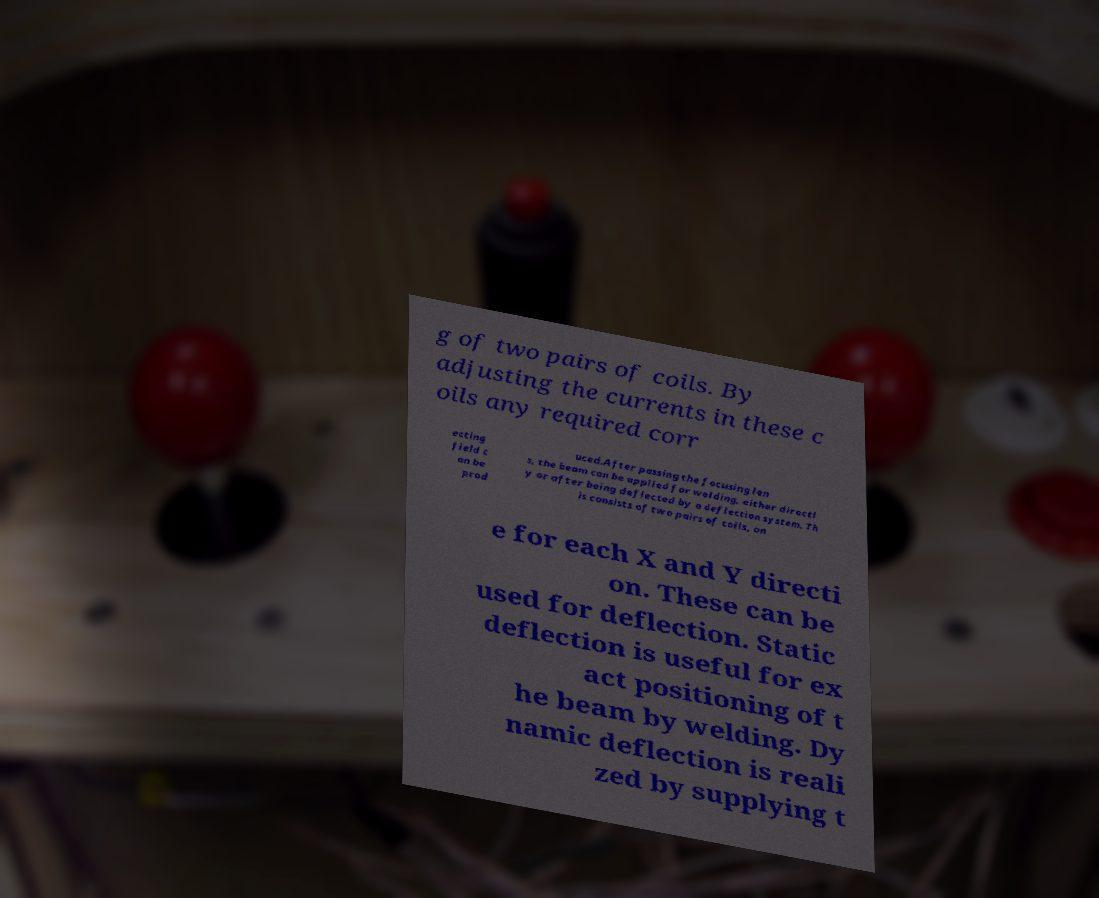What messages or text are displayed in this image? I need them in a readable, typed format. g of two pairs of coils. By adjusting the currents in these c oils any required corr ecting field c an be prod uced.After passing the focusing len s, the beam can be applied for welding, either directl y or after being deflected by a deflection system. Th is consists of two pairs of coils, on e for each X and Y directi on. These can be used for deflection. Static deflection is useful for ex act positioning of t he beam by welding. Dy namic deflection is reali zed by supplying t 